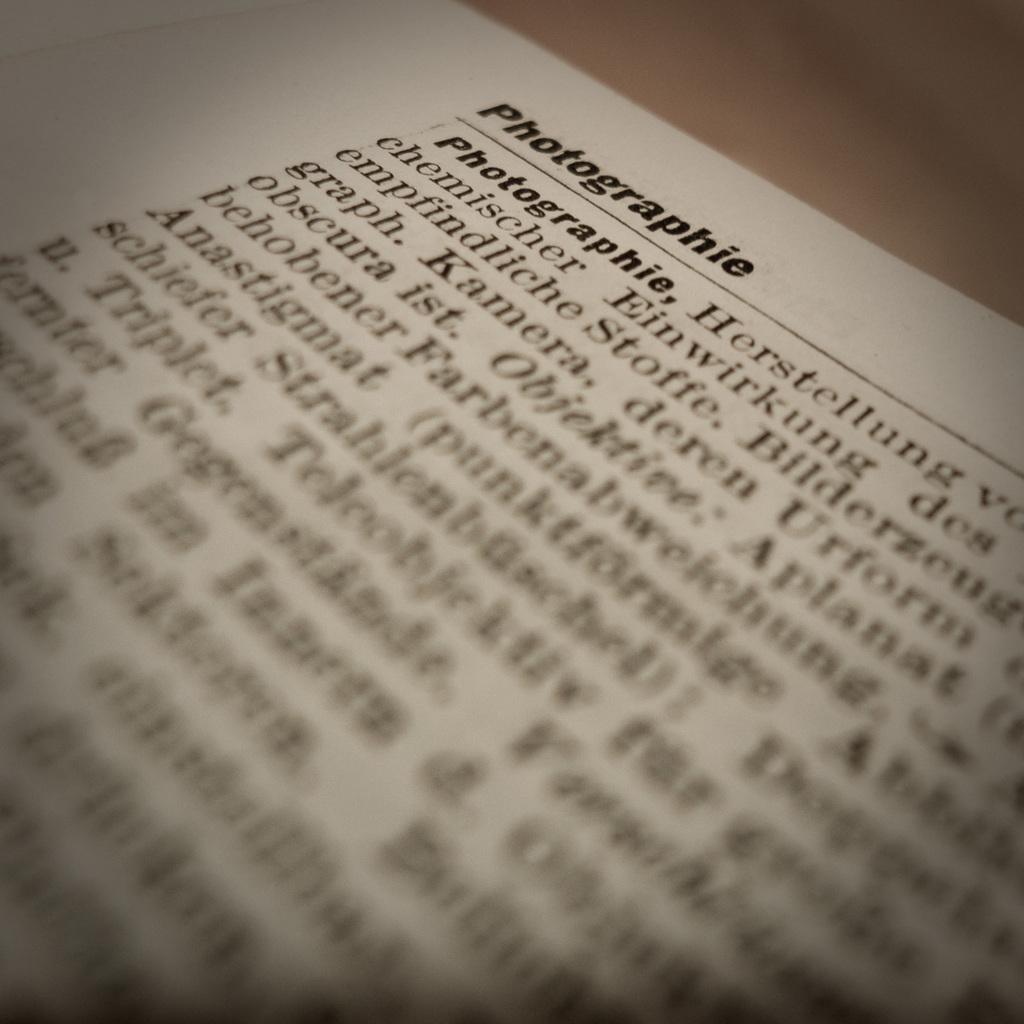What is the title of the page in the book?
Make the answer very short. Photographie. 